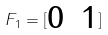Convert formula to latex. <formula><loc_0><loc_0><loc_500><loc_500>F _ { 1 } = [ \begin{matrix} 0 & 1 \end{matrix} ]</formula> 